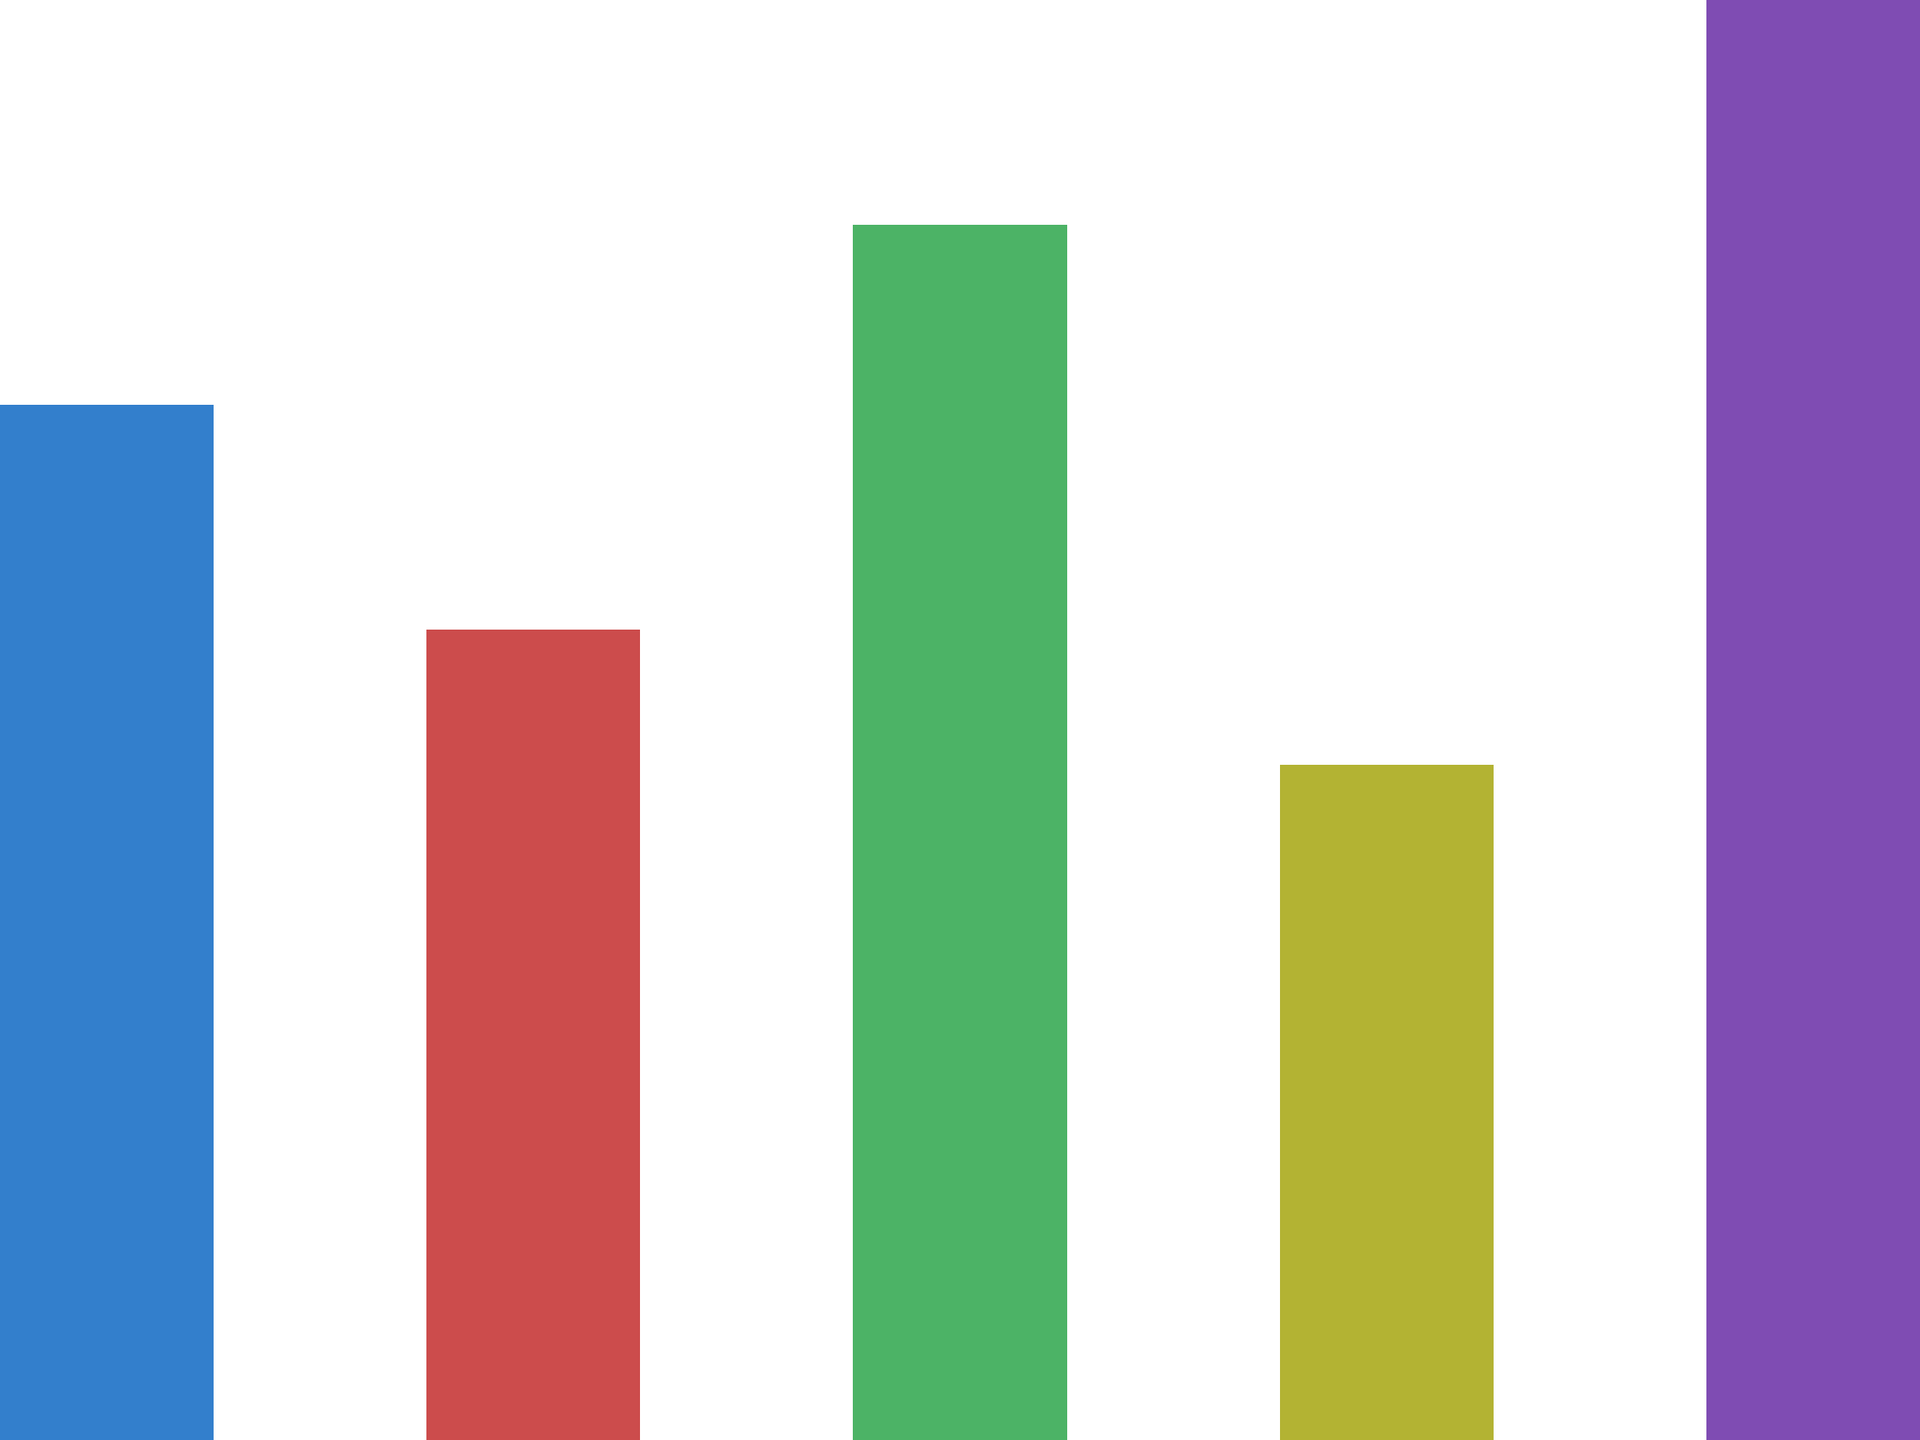Based on the bar chart comparing cost-benefit ratios of different resource allocation strategies, which strategy would you recommend to maximize the company's return on investment, and why? How does this choice align with typical insurance industry practices for resource allocation? To answer this question, we need to analyze the cost-benefit ratios presented in the bar chart for each strategy:

1. Strategy A: Cost-benefit ratio of 2.3
2. Strategy B: Cost-benefit ratio of 1.8
3. Strategy C: Cost-benefit ratio of 2.7
4. Strategy D: Cost-benefit ratio of 1.5
5. Strategy E: Cost-benefit ratio of 3.2

In this context, a higher cost-benefit ratio indicates a better return on investment (ROI). The ratios represent the benefits gained for each unit of cost invested.

Step 1: Identify the highest cost-benefit ratio
Strategy E has the highest ratio at 3.2, meaning it provides the most benefit per unit of cost.

Step 2: Consider industry practices
In the insurance industry, resource allocation typically focuses on:
a) Risk management
b) Claims processing efficiency
c) Customer acquisition and retention
d) Technological improvements

Strategy E's high ratio suggests it might be related to one of these areas, possibly involving process optimization or technology implementation that significantly improves efficiency.

Step 3: Analyze the recommendation
Recommending Strategy E aligns with insurance industry practices by:
1. Maximizing ROI, which is crucial in the highly competitive insurance market
2. Potentially improving operational efficiency, which is vital for insurers
3. Possibly enhancing risk management or claims processing, both key areas in insurance

Step 4: Consider limitations
While Strategy E appears most favorable, it's important to note that:
a) The absolute costs and benefits are not shown, only the ratios
b) There might be implementation challenges or risks not reflected in the ratio
c) A balanced approach using multiple strategies might be more prudent in practice

In conclusion, based solely on the cost-benefit ratios provided, Strategy E would be the recommended choice to maximize the company's return on investment. This aligns with insurance industry practices of seeking the highest efficiency and return in resource allocation, particularly if the strategy relates to core insurance operations like risk management or claims processing.
Answer: Strategy E, with the highest cost-benefit ratio of 3.2, maximizing ROI and aligning with insurance industry focus on efficiency and risk management. 